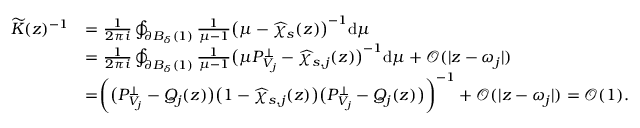<formula> <loc_0><loc_0><loc_500><loc_500>\begin{array} { r l } { \widetilde { K } ( z ) ^ { - 1 } } & { = \frac { 1 } { 2 \pi i } \oint _ { \partial B _ { \delta } ( 1 ) } \frac { 1 } { \mu - 1 } \left ( \mu - \widehat { \chi } _ { s } ( z ) \right ) ^ { - 1 } d \mu } \\ & { = \frac { 1 } { 2 \pi i } \oint _ { \partial B _ { \delta } ( 1 ) } \frac { 1 } { \mu - 1 } \left ( \mu P _ { V _ { j } } ^ { \perp } - \widehat { \chi } _ { s , j } ( z ) \right ) ^ { - 1 } d \mu + \mathcal { O } ( | z - \omega _ { j } | ) } \\ & { = \left ( \left ( P _ { V _ { j } } ^ { \perp } - Q _ { j } ( z ) \right ) \left ( 1 - \widehat { \chi } _ { s , j } ( z ) \right ) \left ( P _ { V _ { j } } ^ { \perp } - Q _ { j } ( z ) \right ) \right ) ^ { - 1 } + \mathcal { O } ( | z - \omega _ { j } | ) = \mathcal { O } ( 1 ) . } \end{array}</formula> 